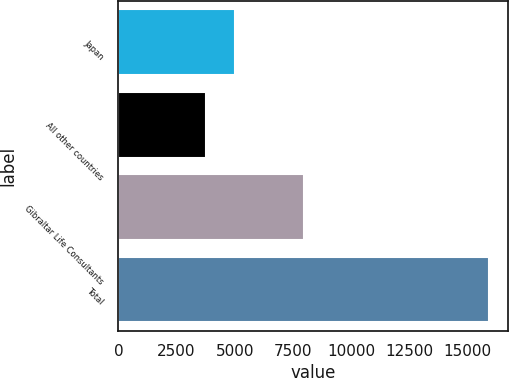Convert chart to OTSL. <chart><loc_0><loc_0><loc_500><loc_500><bar_chart><fcel>Japan<fcel>All other countries<fcel>Gibraltar Life Consultants<fcel>Total<nl><fcel>5000.7<fcel>3786<fcel>7964<fcel>15933<nl></chart> 